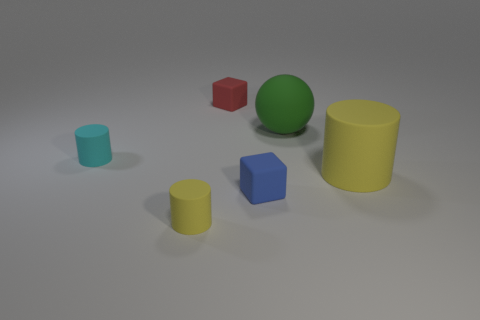Can you describe the colors and shapes of the objects in the image? Certainly! There are six objects in total, each with a distinct color and shape. From left to right, we have a small teal cylinder, a small yellow cylinder, a small blue cube, a red cube, a large green sphere, and a large yellow cylinder with a matte finish. 